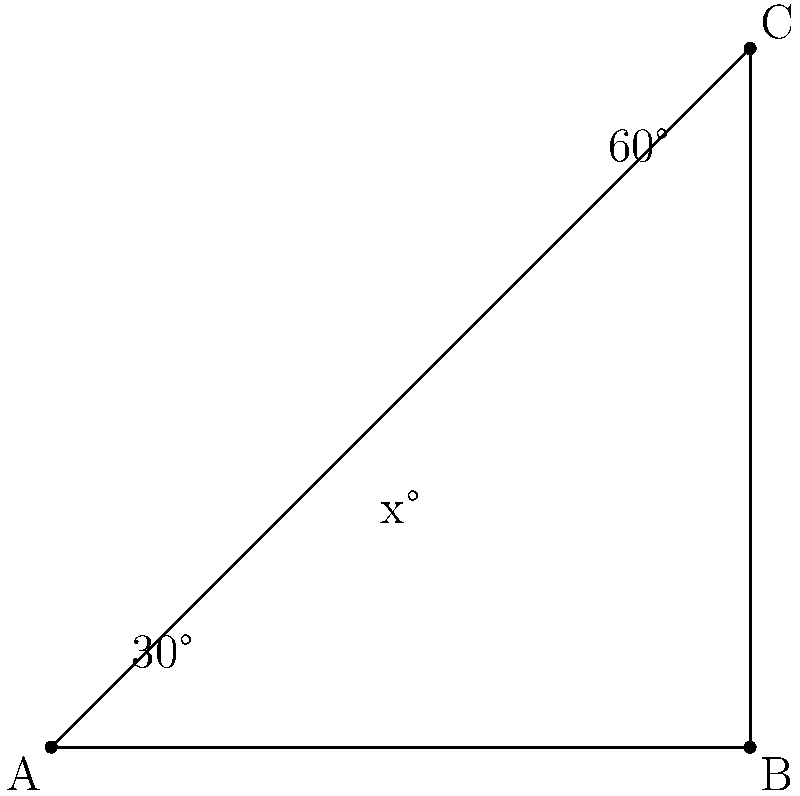You're designing a decorative room divider with angled wooden slats for your luxury hotel. The divider forms a right-angled triangle, with one slat running from corner A to C, creating two smaller triangles. If the angles at corners A and C are 30° and 60° respectively, what is the angle (x°) between the angled slat and the base of the divider? Let's approach this step-by-step:

1) First, recall that the sum of angles in a triangle is always 180°.

2) In the large right-angled triangle ABC:
   - We know that angle B is 90° (right angle)
   - Angle A is given as 30°
   - Angle C is given as 60°
   
3) We can verify: 30° + 90° + 60° = 180°

4) Now, let's focus on the smaller triangle formed by the angled slat:
   - It shares the 30° angle with the larger triangle
   - It has a right angle (90°) where the slat meets the base
   - The third angle is our unknown x°

5) Again, the sum of these angles must be 180°:

   $$30° + 90° + x° = 180°$$

6) Solving for x:
   $$120° + x° = 180°$$
   $$x° = 180° - 120° = 60°$$

Therefore, the angle between the angled slat and the base of the divider is 60°.
Answer: 60° 